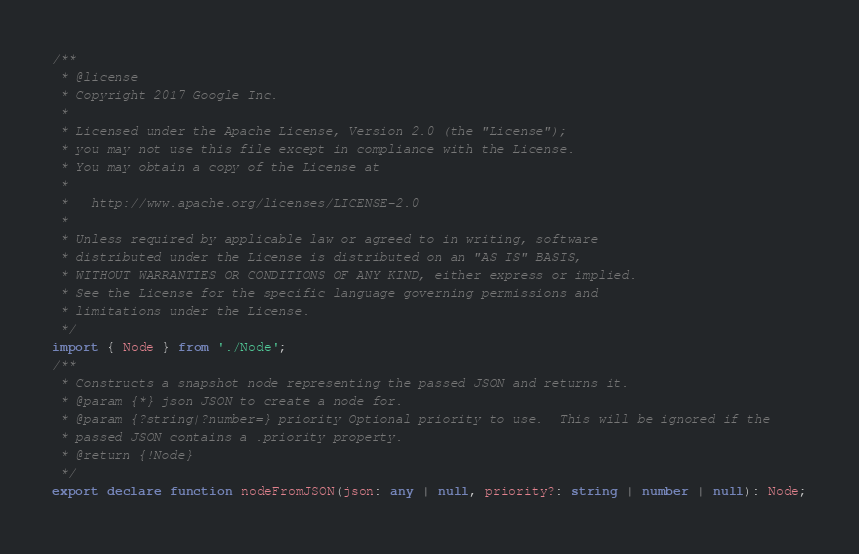Convert code to text. <code><loc_0><loc_0><loc_500><loc_500><_TypeScript_>/**
 * @license
 * Copyright 2017 Google Inc.
 *
 * Licensed under the Apache License, Version 2.0 (the "License");
 * you may not use this file except in compliance with the License.
 * You may obtain a copy of the License at
 *
 *   http://www.apache.org/licenses/LICENSE-2.0
 *
 * Unless required by applicable law or agreed to in writing, software
 * distributed under the License is distributed on an "AS IS" BASIS,
 * WITHOUT WARRANTIES OR CONDITIONS OF ANY KIND, either express or implied.
 * See the License for the specific language governing permissions and
 * limitations under the License.
 */
import { Node } from './Node';
/**
 * Constructs a snapshot node representing the passed JSON and returns it.
 * @param {*} json JSON to create a node for.
 * @param {?string|?number=} priority Optional priority to use.  This will be ignored if the
 * passed JSON contains a .priority property.
 * @return {!Node}
 */
export declare function nodeFromJSON(json: any | null, priority?: string | number | null): Node;
</code> 